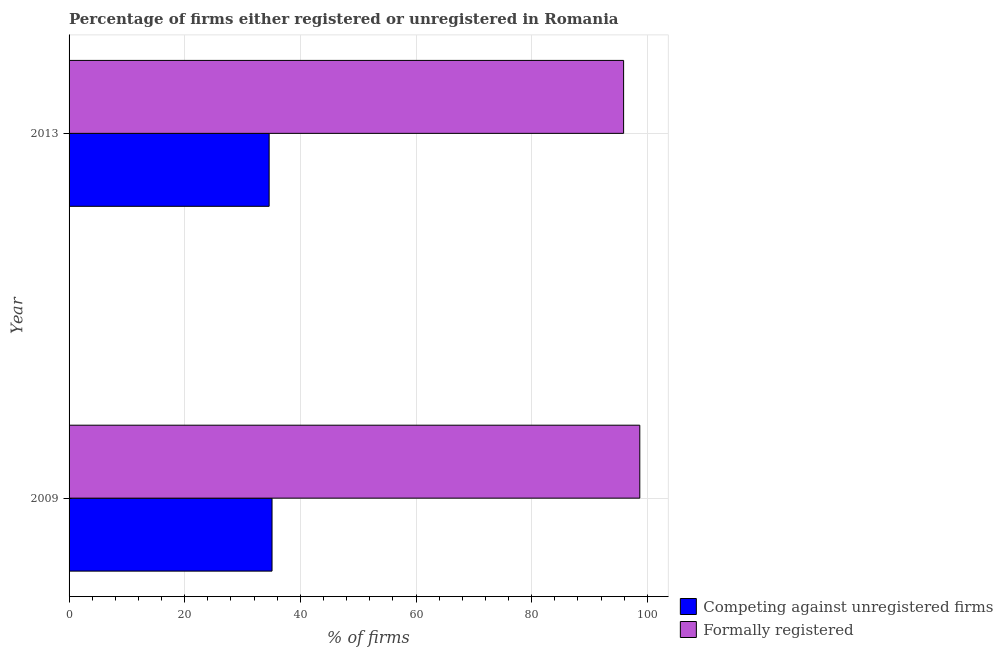How many groups of bars are there?
Offer a very short reply. 2. Are the number of bars on each tick of the Y-axis equal?
Ensure brevity in your answer.  Yes. How many bars are there on the 1st tick from the top?
Provide a succinct answer. 2. In how many cases, is the number of bars for a given year not equal to the number of legend labels?
Your answer should be compact. 0. What is the percentage of formally registered firms in 2013?
Offer a terse response. 95.9. Across all years, what is the maximum percentage of registered firms?
Provide a succinct answer. 35.1. Across all years, what is the minimum percentage of formally registered firms?
Your response must be concise. 95.9. In which year was the percentage of formally registered firms maximum?
Offer a very short reply. 2009. In which year was the percentage of formally registered firms minimum?
Your answer should be very brief. 2013. What is the total percentage of formally registered firms in the graph?
Your answer should be compact. 194.6. What is the difference between the percentage of formally registered firms in 2009 and the percentage of registered firms in 2013?
Offer a terse response. 64.1. What is the average percentage of registered firms per year?
Keep it short and to the point. 34.85. In the year 2009, what is the difference between the percentage of formally registered firms and percentage of registered firms?
Your response must be concise. 63.6. Is the percentage of registered firms in 2009 less than that in 2013?
Your answer should be very brief. No. Is the difference between the percentage of registered firms in 2009 and 2013 greater than the difference between the percentage of formally registered firms in 2009 and 2013?
Keep it short and to the point. No. In how many years, is the percentage of registered firms greater than the average percentage of registered firms taken over all years?
Ensure brevity in your answer.  1. What does the 2nd bar from the top in 2009 represents?
Provide a short and direct response. Competing against unregistered firms. What does the 2nd bar from the bottom in 2013 represents?
Provide a short and direct response. Formally registered. How many bars are there?
Offer a very short reply. 4. Are the values on the major ticks of X-axis written in scientific E-notation?
Your response must be concise. No. What is the title of the graph?
Your answer should be very brief. Percentage of firms either registered or unregistered in Romania. Does "Methane emissions" appear as one of the legend labels in the graph?
Make the answer very short. No. What is the label or title of the X-axis?
Your answer should be compact. % of firms. What is the label or title of the Y-axis?
Your answer should be very brief. Year. What is the % of firms of Competing against unregistered firms in 2009?
Provide a short and direct response. 35.1. What is the % of firms of Formally registered in 2009?
Your answer should be very brief. 98.7. What is the % of firms of Competing against unregistered firms in 2013?
Give a very brief answer. 34.6. What is the % of firms of Formally registered in 2013?
Your answer should be very brief. 95.9. Across all years, what is the maximum % of firms of Competing against unregistered firms?
Keep it short and to the point. 35.1. Across all years, what is the maximum % of firms in Formally registered?
Offer a terse response. 98.7. Across all years, what is the minimum % of firms of Competing against unregistered firms?
Provide a short and direct response. 34.6. Across all years, what is the minimum % of firms of Formally registered?
Offer a very short reply. 95.9. What is the total % of firms of Competing against unregistered firms in the graph?
Offer a terse response. 69.7. What is the total % of firms of Formally registered in the graph?
Offer a very short reply. 194.6. What is the difference between the % of firms of Competing against unregistered firms in 2009 and that in 2013?
Provide a short and direct response. 0.5. What is the difference between the % of firms in Competing against unregistered firms in 2009 and the % of firms in Formally registered in 2013?
Your answer should be very brief. -60.8. What is the average % of firms in Competing against unregistered firms per year?
Provide a succinct answer. 34.85. What is the average % of firms in Formally registered per year?
Make the answer very short. 97.3. In the year 2009, what is the difference between the % of firms of Competing against unregistered firms and % of firms of Formally registered?
Keep it short and to the point. -63.6. In the year 2013, what is the difference between the % of firms in Competing against unregistered firms and % of firms in Formally registered?
Your response must be concise. -61.3. What is the ratio of the % of firms in Competing against unregistered firms in 2009 to that in 2013?
Offer a terse response. 1.01. What is the ratio of the % of firms in Formally registered in 2009 to that in 2013?
Your answer should be compact. 1.03. What is the difference between the highest and the second highest % of firms of Competing against unregistered firms?
Your answer should be very brief. 0.5. What is the difference between the highest and the second highest % of firms in Formally registered?
Provide a succinct answer. 2.8. What is the difference between the highest and the lowest % of firms in Formally registered?
Your answer should be very brief. 2.8. 